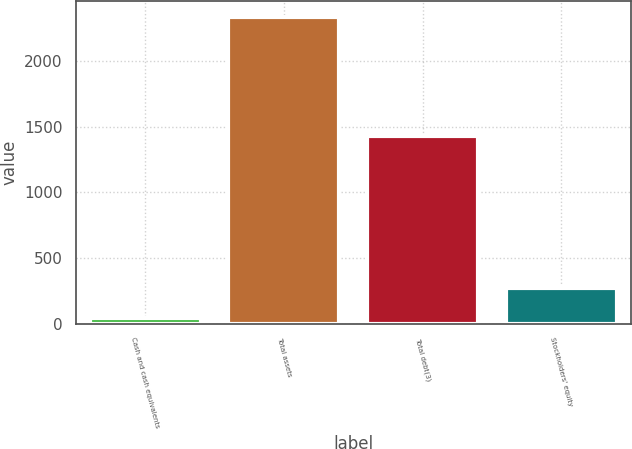Convert chart to OTSL. <chart><loc_0><loc_0><loc_500><loc_500><bar_chart><fcel>Cash and cash equivalents<fcel>Total assets<fcel>Total debt(3)<fcel>Stockholders' equity<nl><fcel>39.3<fcel>2335.1<fcel>1426.7<fcel>268.88<nl></chart> 